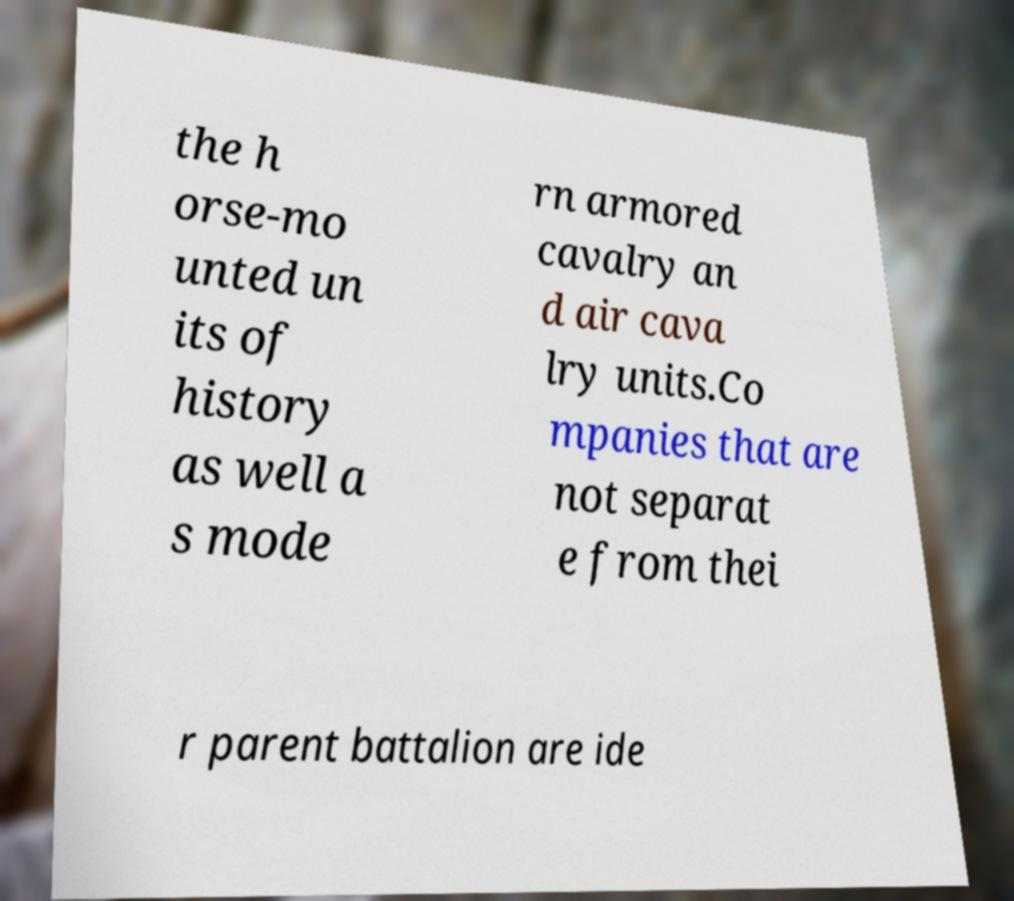Please read and relay the text visible in this image. What does it say? the h orse-mo unted un its of history as well a s mode rn armored cavalry an d air cava lry units.Co mpanies that are not separat e from thei r parent battalion are ide 